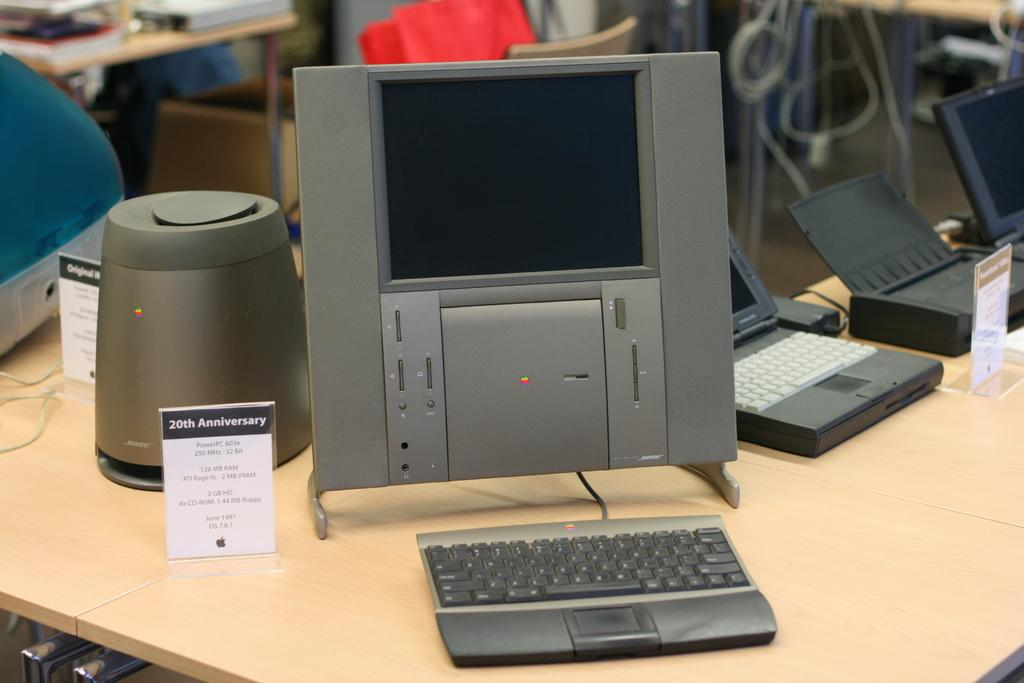<image>
Write a terse but informative summary of the picture. Silver device with a tag next to it saying 20th Anniversary. 